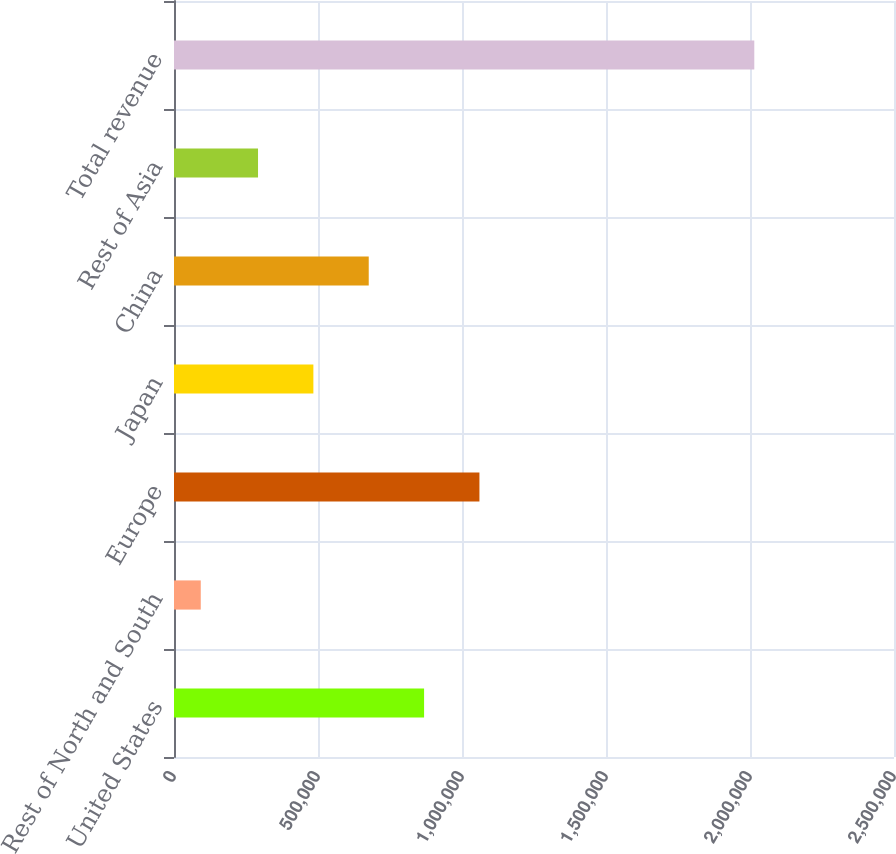Convert chart. <chart><loc_0><loc_0><loc_500><loc_500><bar_chart><fcel>United States<fcel>Rest of North and South<fcel>Europe<fcel>Japan<fcel>China<fcel>Rest of Asia<fcel>Total revenue<nl><fcel>868343<fcel>92954<fcel>1.06054e+06<fcel>483952<fcel>676148<fcel>291757<fcel>2.01491e+06<nl></chart> 